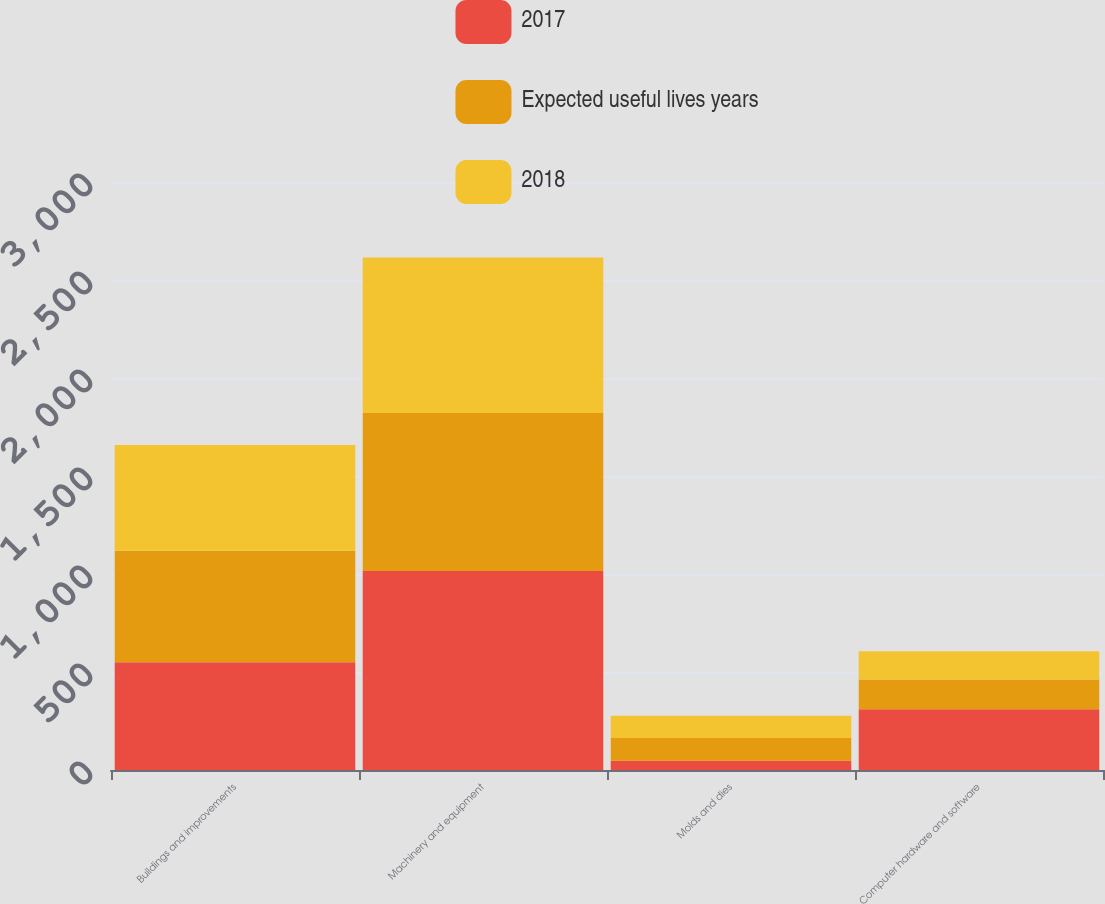Convert chart to OTSL. <chart><loc_0><loc_0><loc_500><loc_500><stacked_bar_chart><ecel><fcel>Buildings and improvements<fcel>Machinery and equipment<fcel>Molds and dies<fcel>Computer hardware and software<nl><fcel>2017<fcel>550<fcel>1015<fcel>47<fcel>310<nl><fcel>Expected useful lives years<fcel>569.1<fcel>806.7<fcel>115.8<fcel>151.1<nl><fcel>2018<fcel>539.2<fcel>793.4<fcel>114.5<fcel>144.6<nl></chart> 